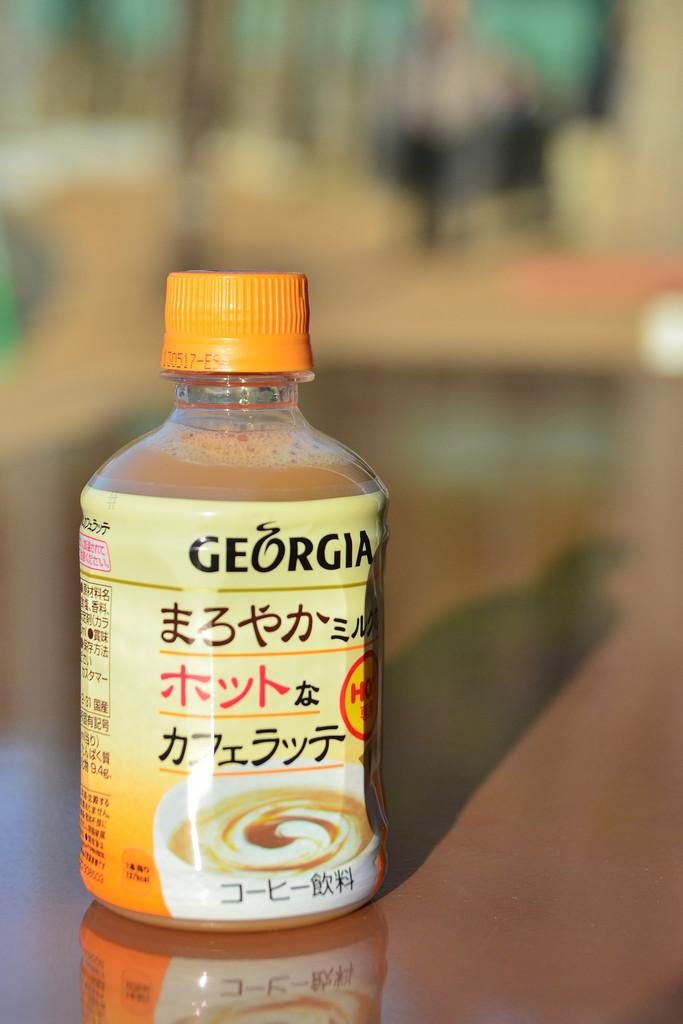Provide a one-sentence caption for the provided image. A bottle of Georgia sauce rests on a tabletop. 